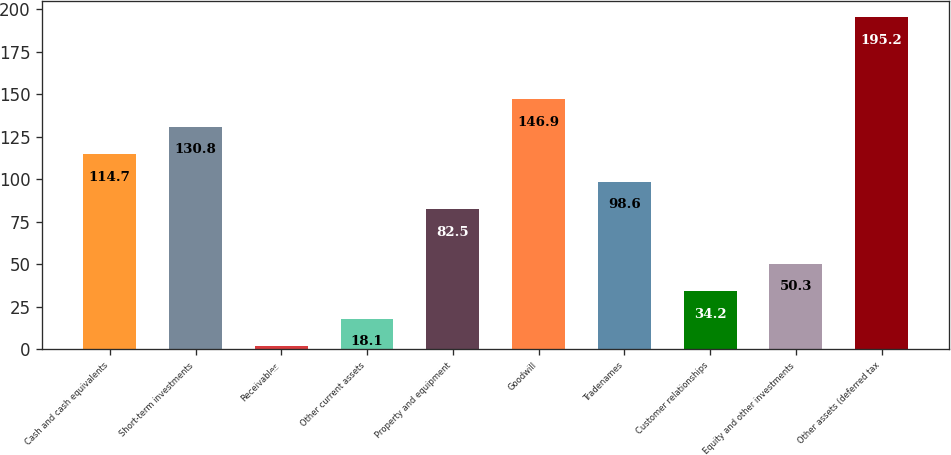<chart> <loc_0><loc_0><loc_500><loc_500><bar_chart><fcel>Cash and cash equivalents<fcel>Short-term investments<fcel>Receivables<fcel>Other current assets<fcel>Property and equipment<fcel>Goodwill<fcel>Tradenames<fcel>Customer relationships<fcel>Equity and other investments<fcel>Other assets (deferred tax<nl><fcel>114.7<fcel>130.8<fcel>2<fcel>18.1<fcel>82.5<fcel>146.9<fcel>98.6<fcel>34.2<fcel>50.3<fcel>195.2<nl></chart> 